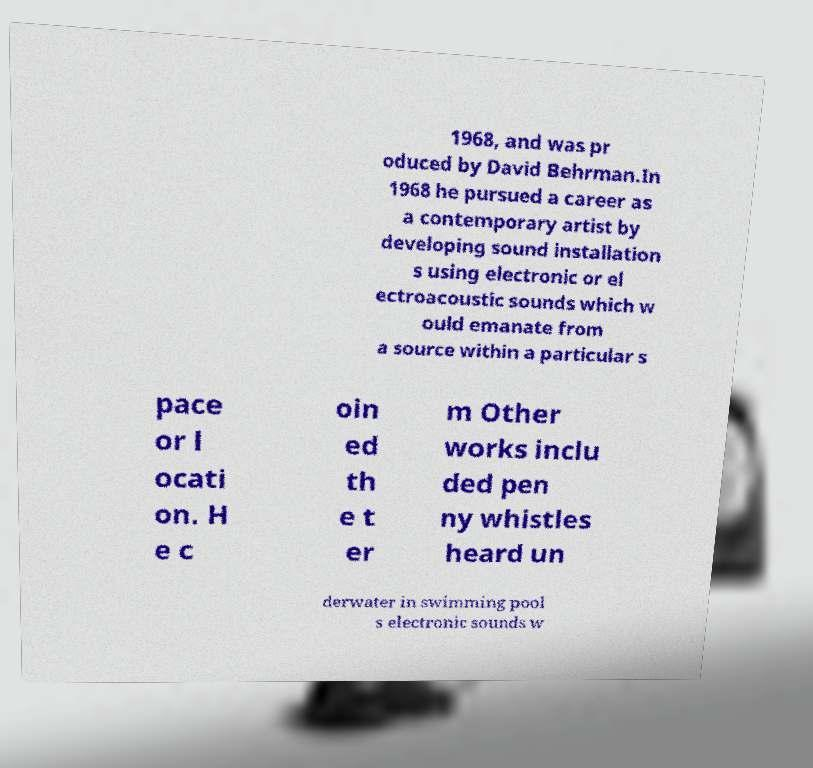Could you extract and type out the text from this image? 1968, and was pr oduced by David Behrman.In 1968 he pursued a career as a contemporary artist by developing sound installation s using electronic or el ectroacoustic sounds which w ould emanate from a source within a particular s pace or l ocati on. H e c oin ed th e t er m Other works inclu ded pen ny whistles heard un derwater in swimming pool s electronic sounds w 